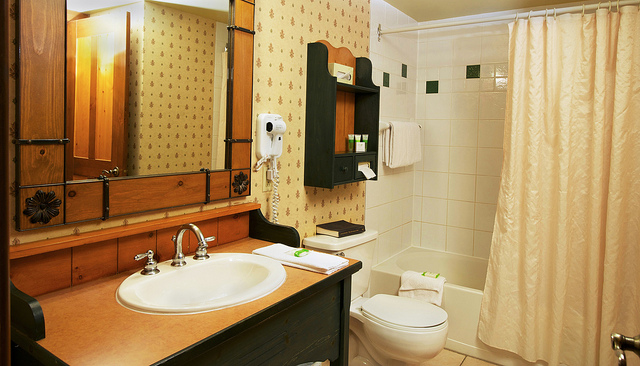Can you describe the style of the bathroom? The bathroom has a classic and somewhat rustic style, featuring wooden accents and a patterned wallpaper. The color palette consists of warm tones, giving it a cozy and comfortable feel. 